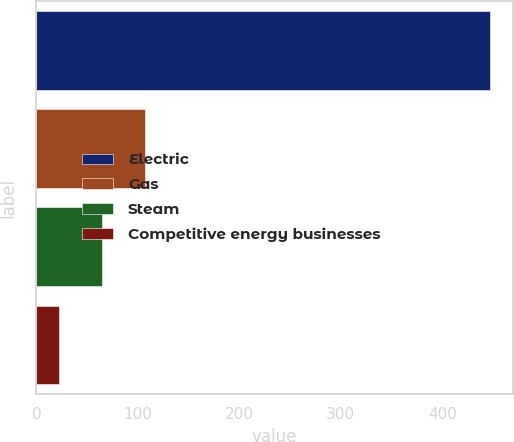<chart> <loc_0><loc_0><loc_500><loc_500><bar_chart><fcel>Electric<fcel>Gas<fcel>Steam<fcel>Competitive energy businesses<nl><fcel>447<fcel>107<fcel>64.5<fcel>22<nl></chart> 